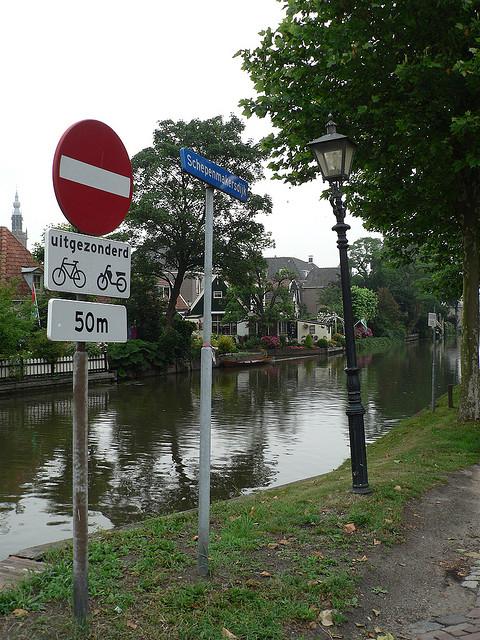Is it raining here?
Be succinct. Yes. What does the white sign say?
Concise answer only. 50m. Is this a river?
Be succinct. Yes. What language is on the signs?
Write a very short answer. German. What does the sign say?
Keep it brief. 50m. 